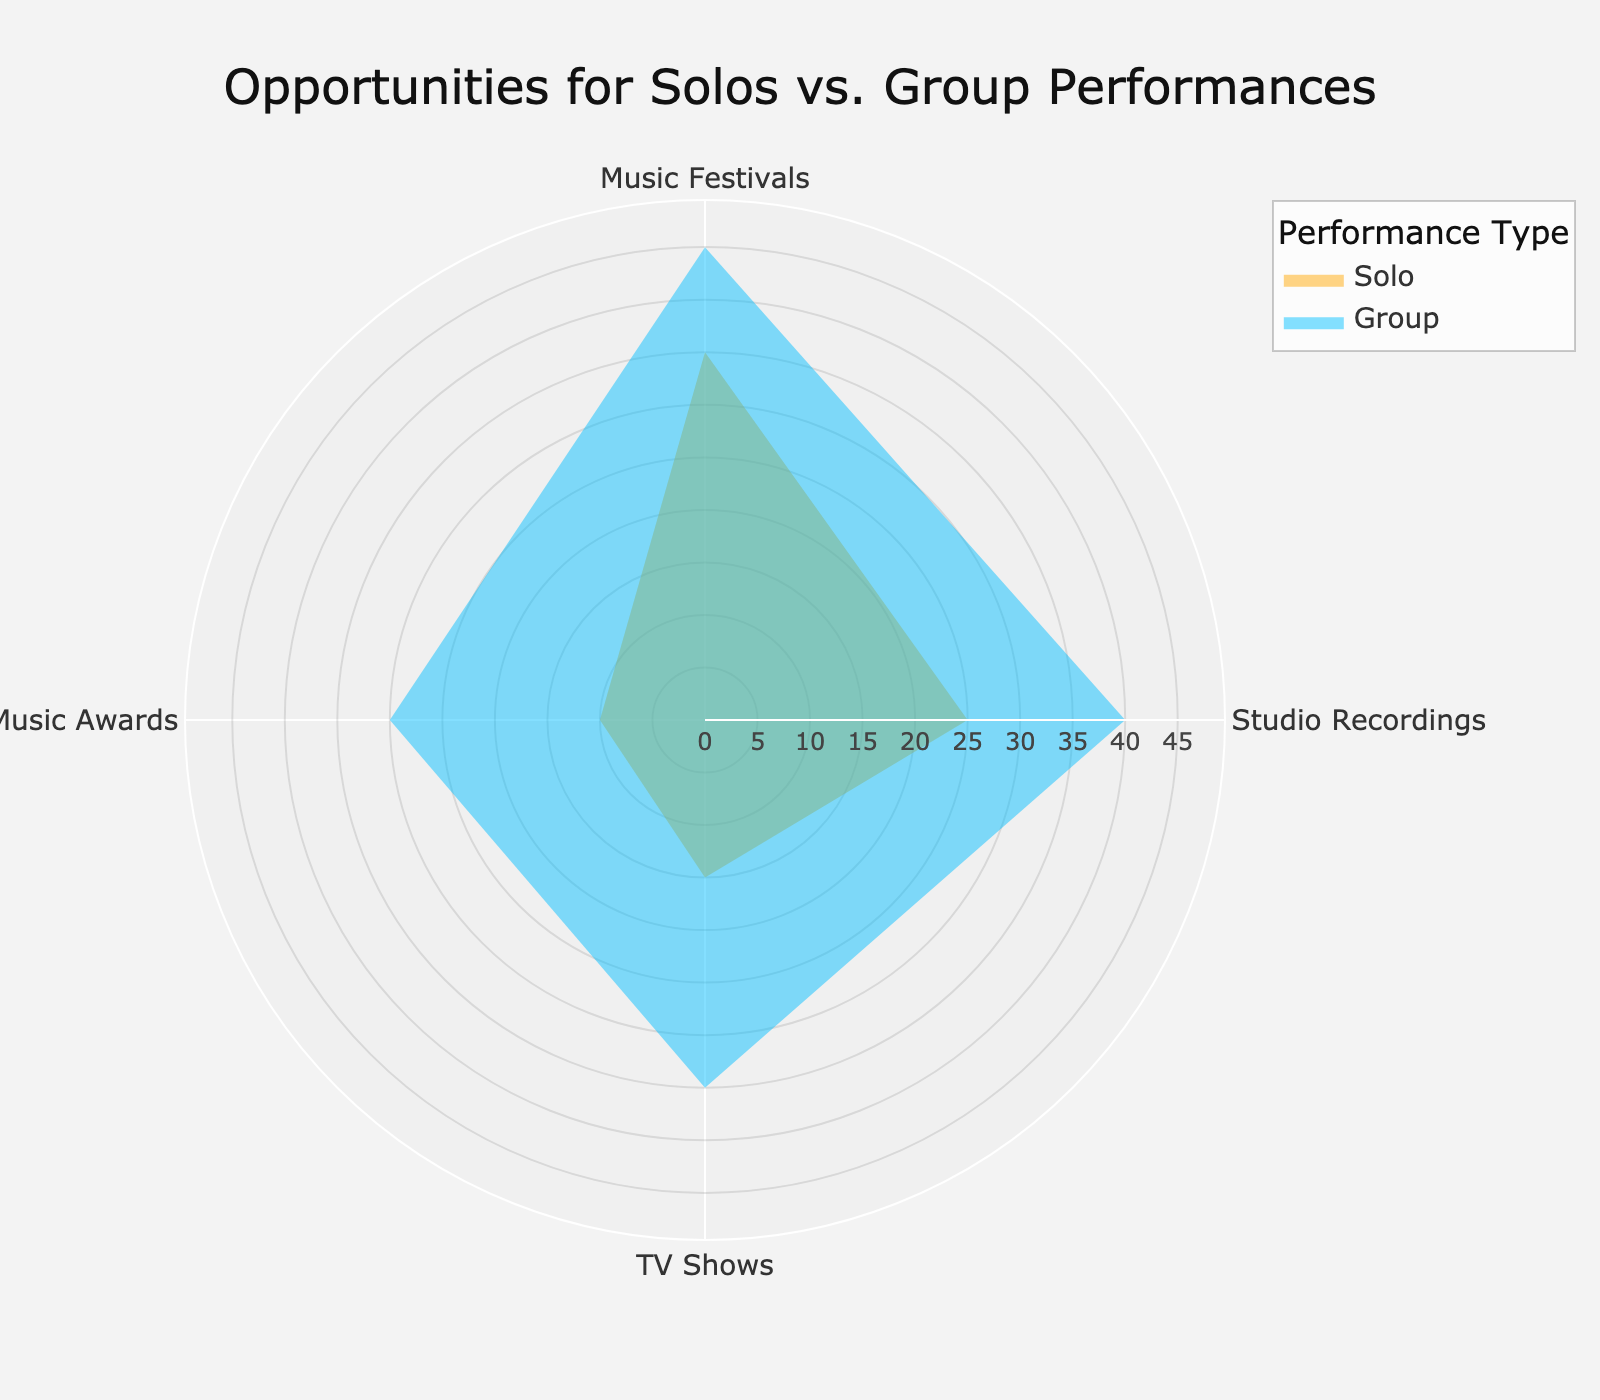What is the title of the figure? The title is usually placed at the top of the figure and describes the overall content. In this case, it would be visible at the top center of the plot.
Answer: Opportunities for Solos vs. Group Performances Which performance type has a higher percentage in Music Festivals? To determine this, compare the 'Solo' and 'Group' traces at the 'Music Festivals' section. The 'Group' trace is visibly longer.
Answer: Group What is the smallest percentage value for Solo performances, and at which event does it occur? Look at the lengths of the 'Solo' traces. The shortest trace represents the event 'Music Awards'.
Answer: 10%, Music Awards How do the percentages for Solo and Group performances compare in Studio Recordings? Compare the two radial extents at the 'Studio Recordings' section. The 'Solo' trace is shorter than the 'Group' trace.
Answer: Solo: 25%, Group: 40% What's the sum of all percentage values for Group performances? Sum the percentages for the 'Group' trace: 45 (Music Festivals) + 40 (Studio Recordings) + 35 (TV Shows) + 30 (Music Awards) = 150
Answer: 150 Which event has the biggest difference in percentages between Solo and Group performances, and what is that difference? Subtract the 'Solo' percentage from the 'Group' percentage for each event. The biggest difference is at 'Music Awards': 30 - 10 = 20
Answer: Music Awards, 20 Is there any event where the percentage of Solo performances is equal to the percentage of Group performances? Compare the 'Solo' and 'Group' traces for each event. There is no event where the traces are the same length.
Answer: No For which event is the percentage of Group performances the most dominant compared to Solo performances? Identify where the 'Group' trace significantly surpasses the 'Solo' trace. This is most notable at 'Music Awards'.
Answer: Music Awards What is the range of the radial axis? The radial axis range is given in the figure's layout, extending from 0 to slightly above the highest percentage. The highest value is 45, so the range would be 0 to 49.5 (110% of 45).
Answer: 0 to 49.5 Which performance type has more opportunities on TV Shows? Compare the 'Solo' and 'Group' traces at 'TV Shows'. The 'Group' trace is longer.
Answer: Group 